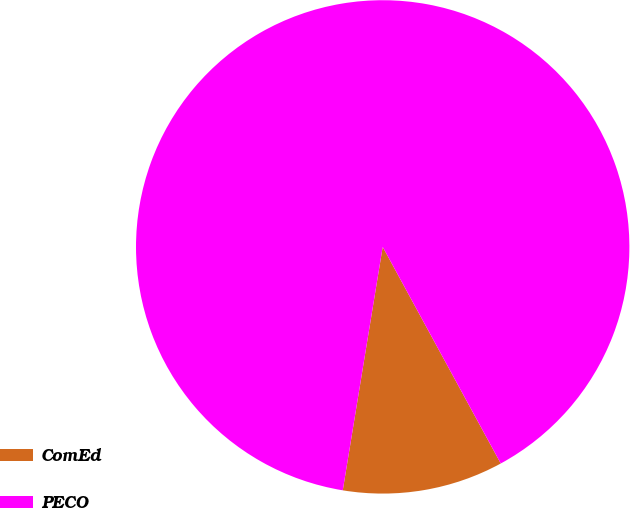Convert chart. <chart><loc_0><loc_0><loc_500><loc_500><pie_chart><fcel>ComEd<fcel>PECO<nl><fcel>10.53%<fcel>89.47%<nl></chart> 